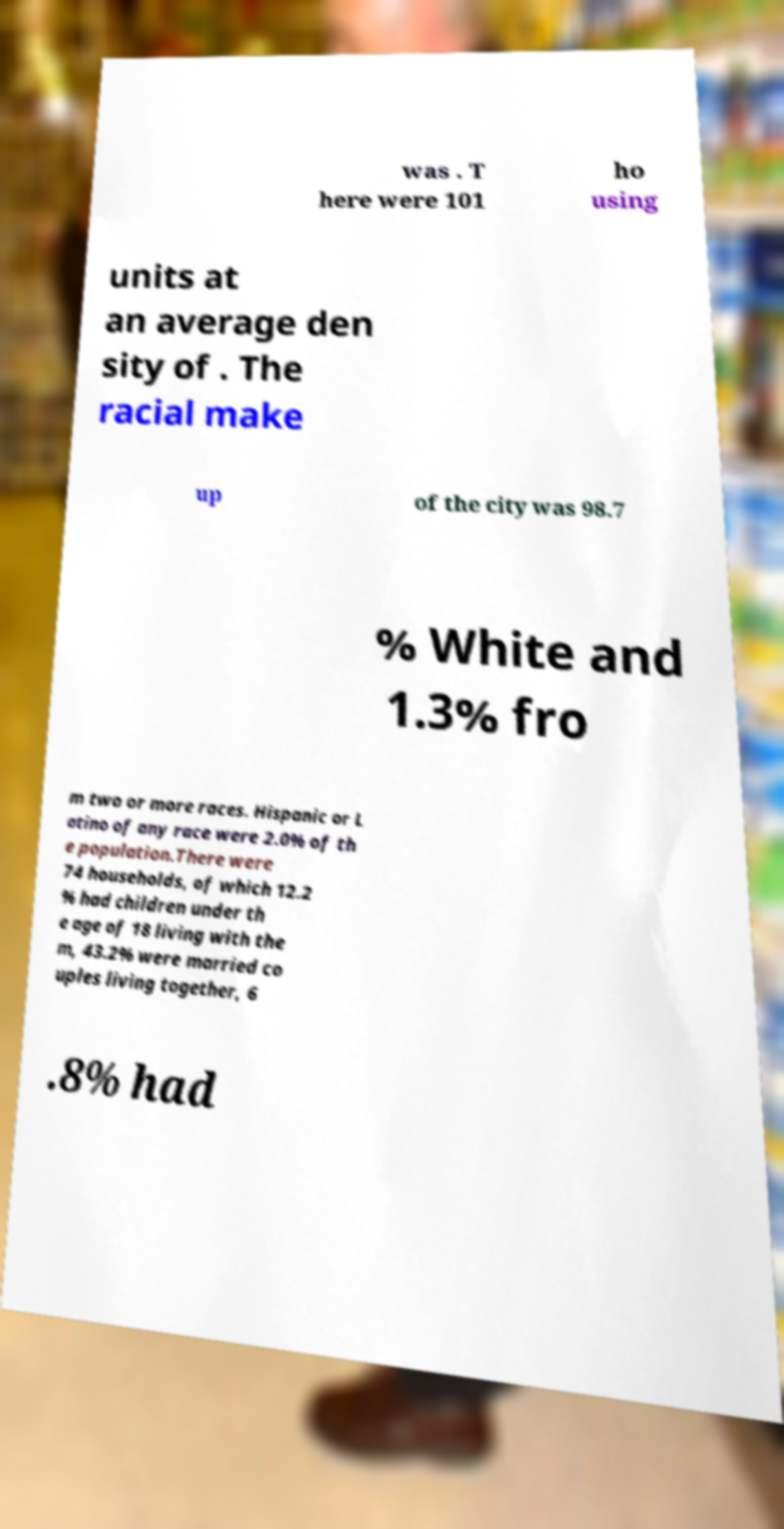Can you read and provide the text displayed in the image?This photo seems to have some interesting text. Can you extract and type it out for me? was . T here were 101 ho using units at an average den sity of . The racial make up of the city was 98.7 % White and 1.3% fro m two or more races. Hispanic or L atino of any race were 2.0% of th e population.There were 74 households, of which 12.2 % had children under th e age of 18 living with the m, 43.2% were married co uples living together, 6 .8% had 